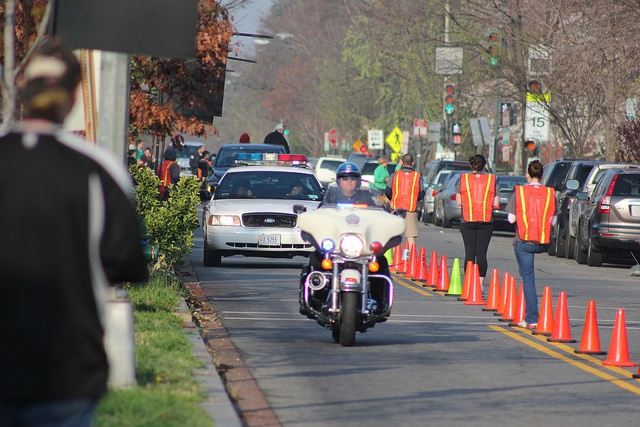Describe the objects in this image and their specific colors. I can see people in black, gray, and darkgray tones, motorcycle in black, ivory, gray, and darkgray tones, car in black, lightgray, navy, and darkgray tones, car in black, gray, darkgray, and lightgray tones, and people in black, salmon, gray, and blue tones in this image. 